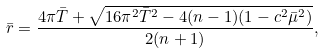Convert formula to latex. <formula><loc_0><loc_0><loc_500><loc_500>\bar { r } = \frac { 4 \pi \bar { T } + { \sqrt { 1 6 \pi ^ { 2 } \bar { T } ^ { 2 } - 4 ( n - 1 ) ( 1 - c ^ { 2 } \bar { \mu } ^ { 2 } ) } } } { 2 ( n + 1 ) } ,</formula> 